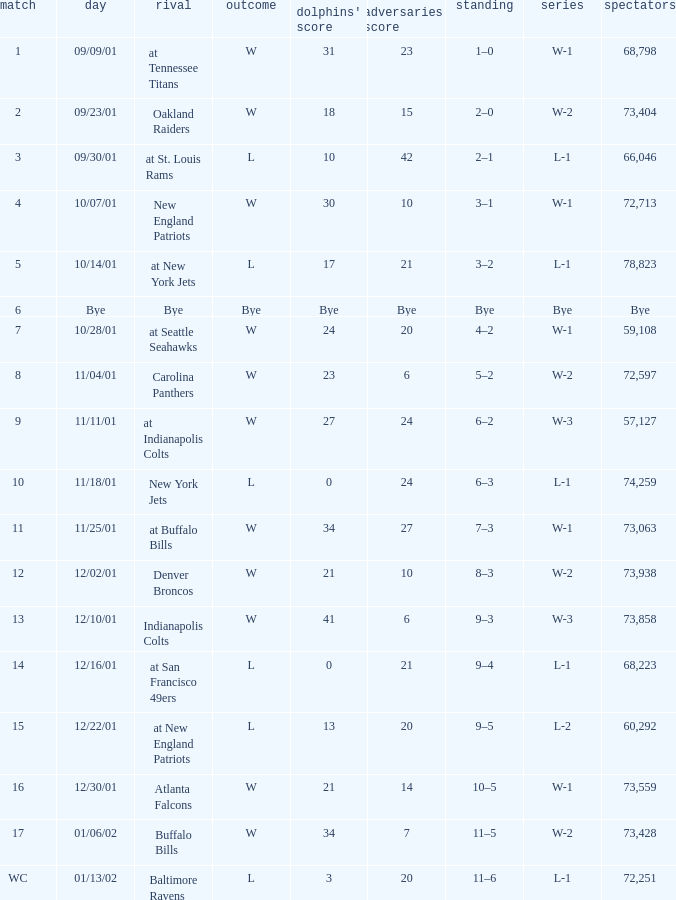What is the streak for game 16 when the Dolphins had 21 points? W-1. 